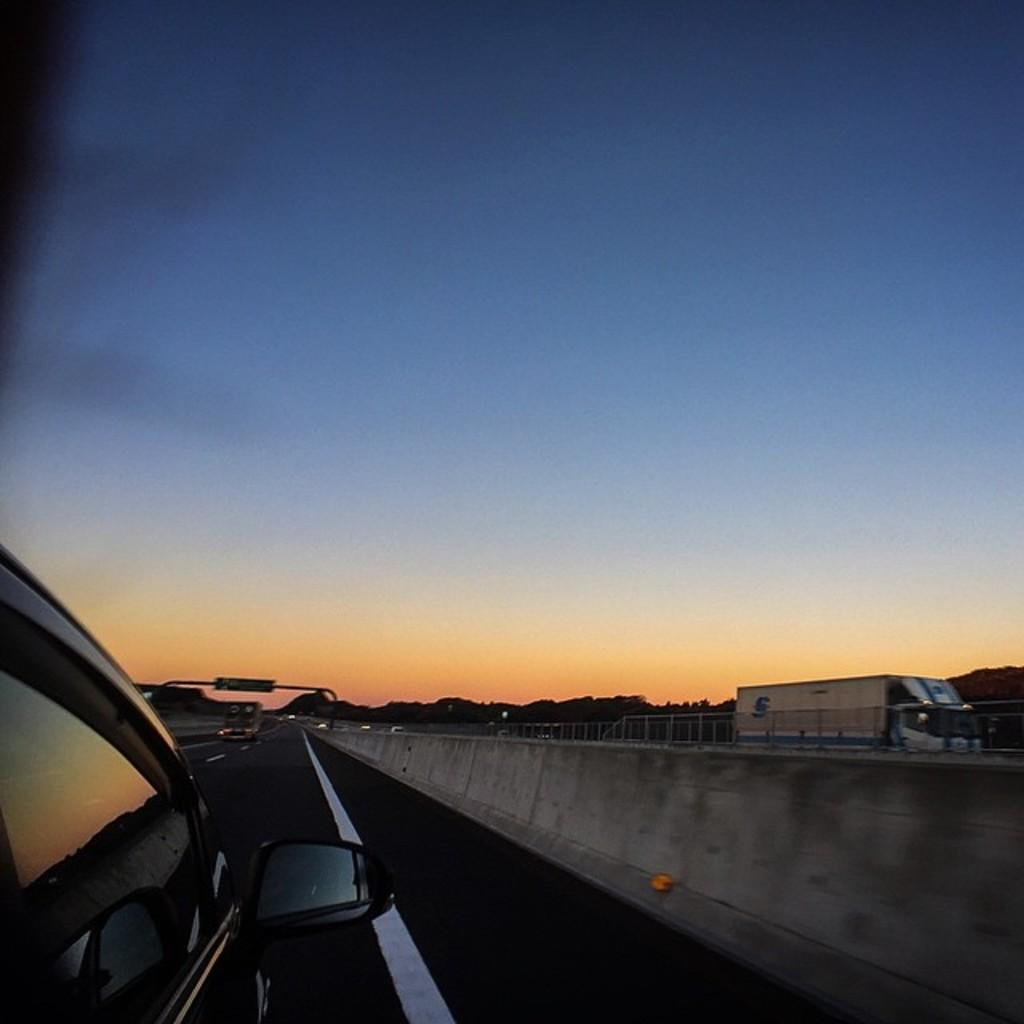What types of vehicles are at the bottom of the image? The specific types of vehicles are not mentioned, but there are vehicles at the bottom of the image. What is located at the bottom of the image along with the vehicles? There is a road, a wall, railing, lights, and trees at the bottom of the image. What can be seen in the background of the image? The sky is visible in the background of the image. What type of badge is being worn by the tree in the image? There are no badges present in the image, and trees do not wear badges. Can you see any bats flying in the image? There are no bats visible in the image. 